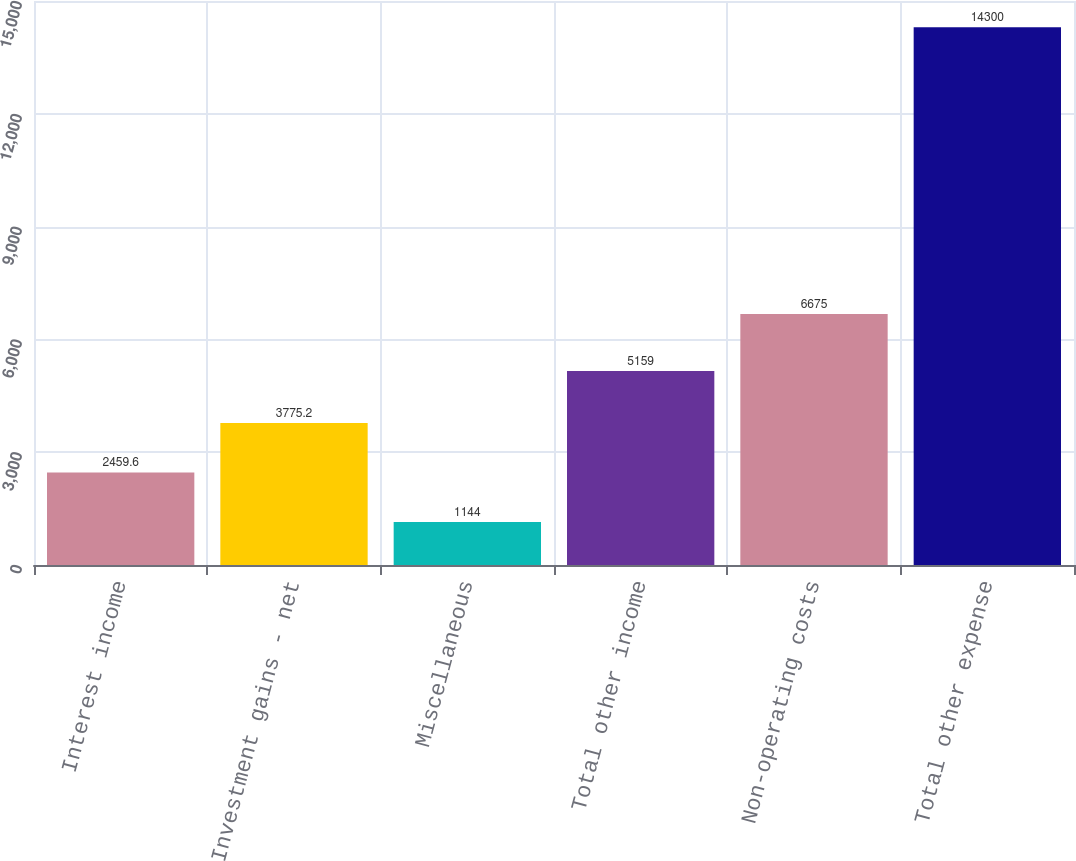Convert chart to OTSL. <chart><loc_0><loc_0><loc_500><loc_500><bar_chart><fcel>Interest income<fcel>Investment gains - net<fcel>Miscellaneous<fcel>Total other income<fcel>Non-operating costs<fcel>Total other expense<nl><fcel>2459.6<fcel>3775.2<fcel>1144<fcel>5159<fcel>6675<fcel>14300<nl></chart> 